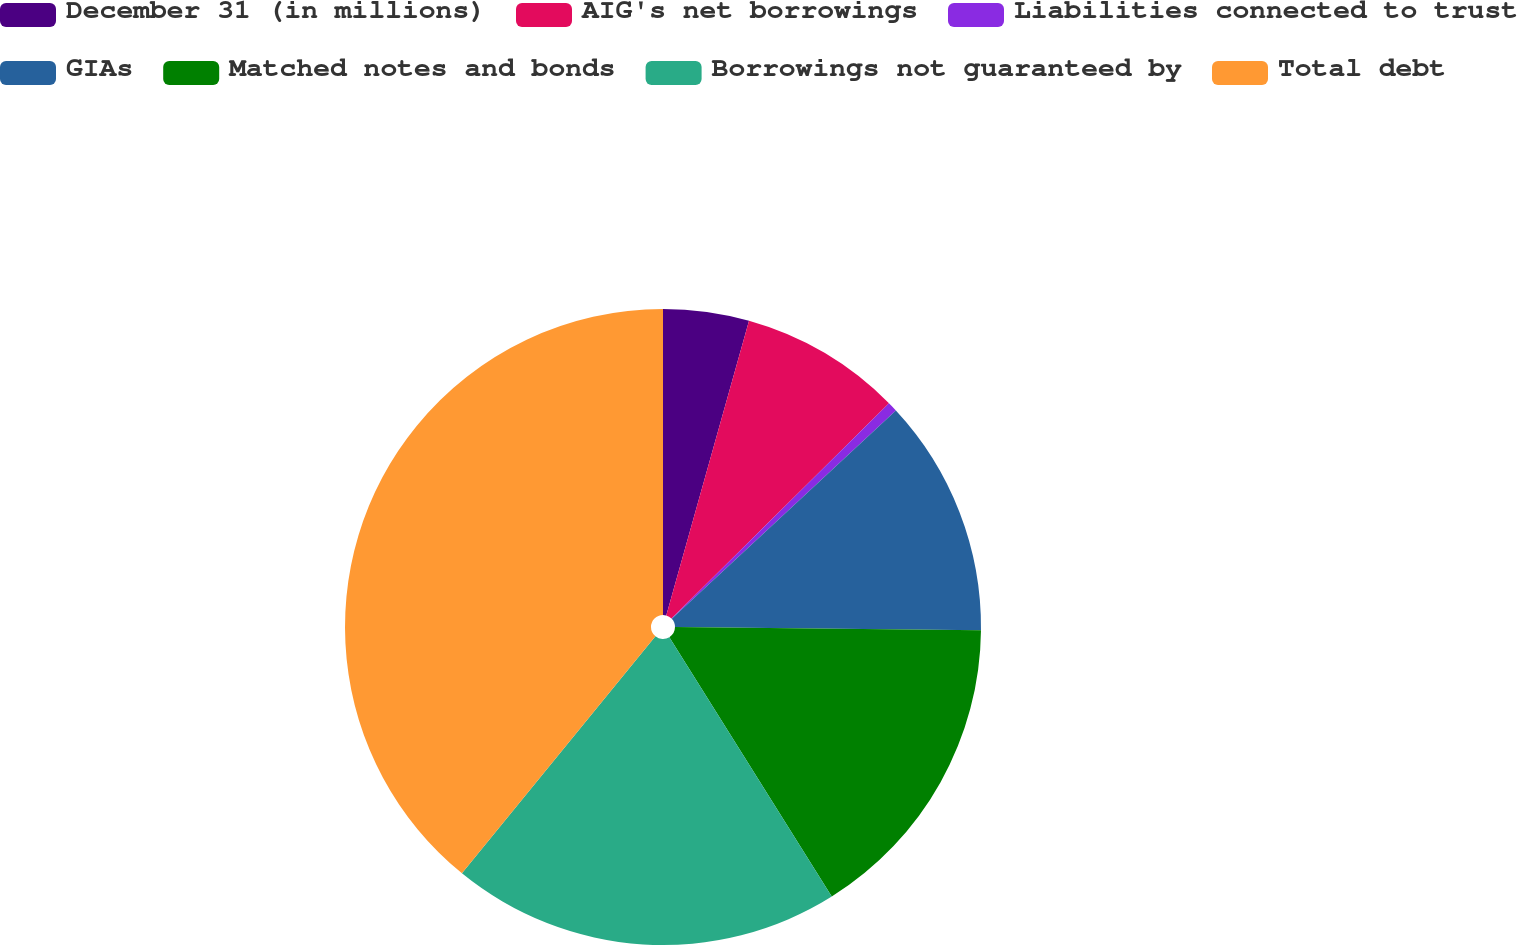Convert chart to OTSL. <chart><loc_0><loc_0><loc_500><loc_500><pie_chart><fcel>December 31 (in millions)<fcel>AIG's net borrowings<fcel>Liabilities connected to trust<fcel>GIAs<fcel>Matched notes and bonds<fcel>Borrowings not guaranteed by<fcel>Total debt<nl><fcel>4.36%<fcel>8.22%<fcel>0.5%<fcel>12.08%<fcel>15.94%<fcel>19.8%<fcel>39.11%<nl></chart> 